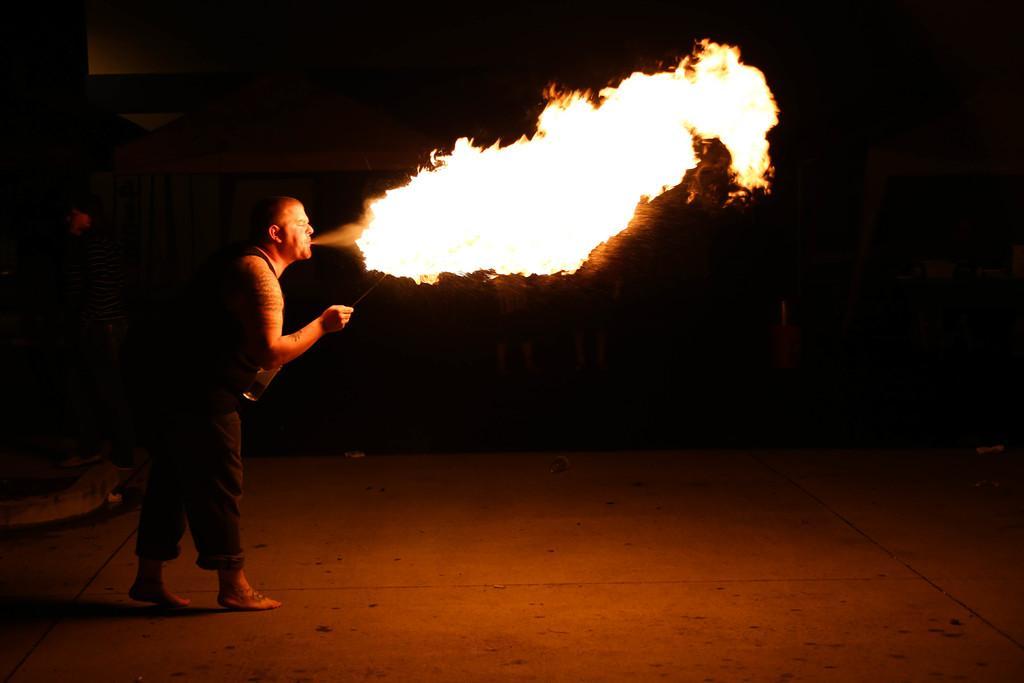In one or two sentences, can you explain what this image depicts? In this image we can see a man is standing on the ground, here is the fire, here it is dark. 